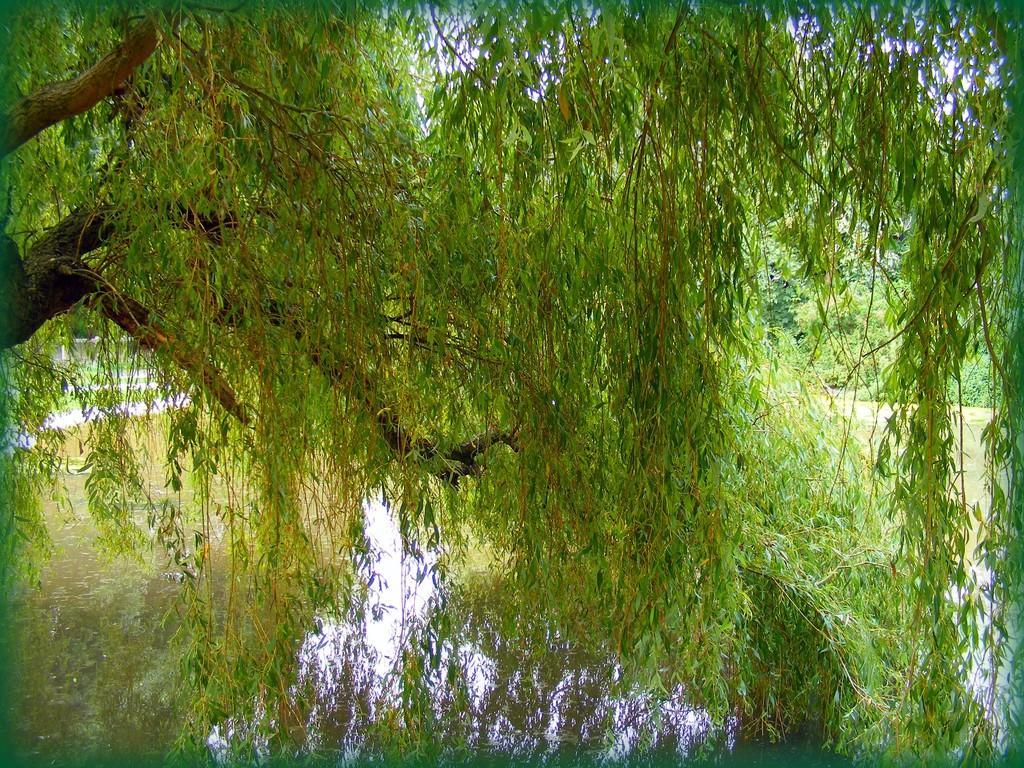How would you summarize this image in a sentence or two? In this picture there are trees and there is water. 